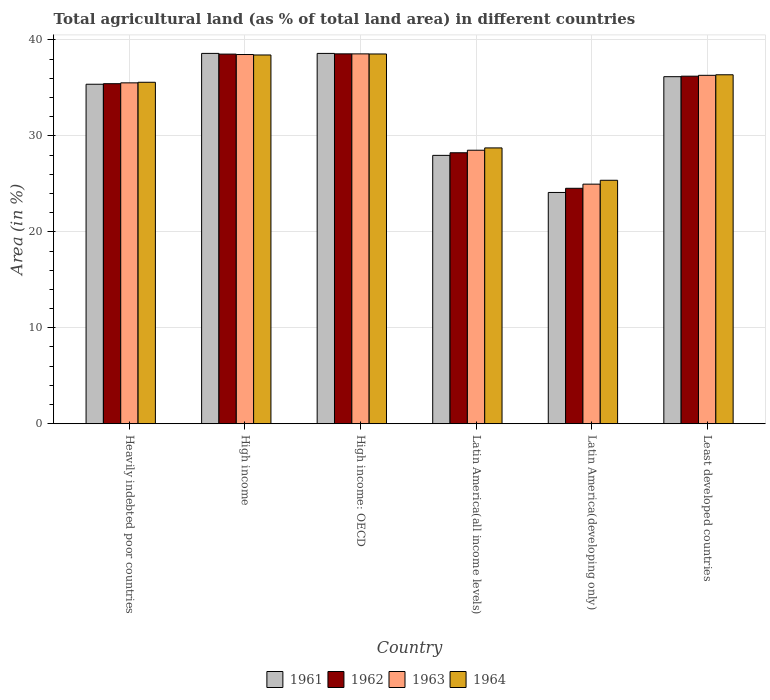How many groups of bars are there?
Your response must be concise. 6. Are the number of bars on each tick of the X-axis equal?
Make the answer very short. Yes. How many bars are there on the 4th tick from the right?
Ensure brevity in your answer.  4. What is the label of the 4th group of bars from the left?
Make the answer very short. Latin America(all income levels). What is the percentage of agricultural land in 1963 in Heavily indebted poor countries?
Make the answer very short. 35.52. Across all countries, what is the maximum percentage of agricultural land in 1964?
Make the answer very short. 38.53. Across all countries, what is the minimum percentage of agricultural land in 1961?
Offer a very short reply. 24.1. In which country was the percentage of agricultural land in 1964 maximum?
Give a very brief answer. High income: OECD. In which country was the percentage of agricultural land in 1962 minimum?
Offer a very short reply. Latin America(developing only). What is the total percentage of agricultural land in 1961 in the graph?
Keep it short and to the point. 200.81. What is the difference between the percentage of agricultural land in 1961 in Latin America(developing only) and that in Least developed countries?
Provide a short and direct response. -12.07. What is the difference between the percentage of agricultural land in 1964 in Latin America(all income levels) and the percentage of agricultural land in 1962 in High income: OECD?
Offer a very short reply. -9.8. What is the average percentage of agricultural land in 1962 per country?
Your response must be concise. 33.58. What is the difference between the percentage of agricultural land of/in 1964 and percentage of agricultural land of/in 1962 in High income?
Ensure brevity in your answer.  -0.09. What is the ratio of the percentage of agricultural land in 1961 in Heavily indebted poor countries to that in High income?
Provide a short and direct response. 0.92. What is the difference between the highest and the second highest percentage of agricultural land in 1962?
Provide a short and direct response. 2.3. What is the difference between the highest and the lowest percentage of agricultural land in 1962?
Keep it short and to the point. 14.01. Is the sum of the percentage of agricultural land in 1964 in Heavily indebted poor countries and Latin America(all income levels) greater than the maximum percentage of agricultural land in 1961 across all countries?
Provide a short and direct response. Yes. Is it the case that in every country, the sum of the percentage of agricultural land in 1963 and percentage of agricultural land in 1961 is greater than the sum of percentage of agricultural land in 1962 and percentage of agricultural land in 1964?
Give a very brief answer. No. What does the 1st bar from the right in Heavily indebted poor countries represents?
Offer a very short reply. 1964. How many bars are there?
Provide a short and direct response. 24. Are all the bars in the graph horizontal?
Give a very brief answer. No. How many countries are there in the graph?
Your answer should be compact. 6. What is the difference between two consecutive major ticks on the Y-axis?
Give a very brief answer. 10. Where does the legend appear in the graph?
Provide a succinct answer. Bottom center. How many legend labels are there?
Offer a terse response. 4. What is the title of the graph?
Offer a terse response. Total agricultural land (as % of total land area) in different countries. Does "1986" appear as one of the legend labels in the graph?
Make the answer very short. No. What is the label or title of the X-axis?
Ensure brevity in your answer.  Country. What is the label or title of the Y-axis?
Provide a short and direct response. Area (in %). What is the Area (in %) of 1961 in Heavily indebted poor countries?
Make the answer very short. 35.38. What is the Area (in %) in 1962 in Heavily indebted poor countries?
Make the answer very short. 35.44. What is the Area (in %) of 1963 in Heavily indebted poor countries?
Give a very brief answer. 35.52. What is the Area (in %) of 1964 in Heavily indebted poor countries?
Your response must be concise. 35.59. What is the Area (in %) of 1961 in High income?
Your response must be concise. 38.59. What is the Area (in %) of 1962 in High income?
Your answer should be compact. 38.52. What is the Area (in %) in 1963 in High income?
Give a very brief answer. 38.48. What is the Area (in %) of 1964 in High income?
Your answer should be very brief. 38.43. What is the Area (in %) of 1961 in High income: OECD?
Provide a succinct answer. 38.59. What is the Area (in %) in 1962 in High income: OECD?
Keep it short and to the point. 38.55. What is the Area (in %) of 1963 in High income: OECD?
Offer a terse response. 38.54. What is the Area (in %) in 1964 in High income: OECD?
Your answer should be very brief. 38.53. What is the Area (in %) of 1961 in Latin America(all income levels)?
Provide a short and direct response. 27.97. What is the Area (in %) of 1962 in Latin America(all income levels)?
Keep it short and to the point. 28.24. What is the Area (in %) in 1963 in Latin America(all income levels)?
Offer a terse response. 28.5. What is the Area (in %) in 1964 in Latin America(all income levels)?
Provide a short and direct response. 28.74. What is the Area (in %) of 1961 in Latin America(developing only)?
Offer a very short reply. 24.1. What is the Area (in %) of 1962 in Latin America(developing only)?
Your response must be concise. 24.54. What is the Area (in %) in 1963 in Latin America(developing only)?
Your answer should be very brief. 24.97. What is the Area (in %) of 1964 in Latin America(developing only)?
Keep it short and to the point. 25.37. What is the Area (in %) in 1961 in Least developed countries?
Your answer should be very brief. 36.17. What is the Area (in %) of 1962 in Least developed countries?
Offer a terse response. 36.22. What is the Area (in %) of 1963 in Least developed countries?
Provide a succinct answer. 36.31. What is the Area (in %) in 1964 in Least developed countries?
Your answer should be very brief. 36.37. Across all countries, what is the maximum Area (in %) of 1961?
Your answer should be compact. 38.59. Across all countries, what is the maximum Area (in %) in 1962?
Provide a succinct answer. 38.55. Across all countries, what is the maximum Area (in %) in 1963?
Your answer should be compact. 38.54. Across all countries, what is the maximum Area (in %) in 1964?
Ensure brevity in your answer.  38.53. Across all countries, what is the minimum Area (in %) of 1961?
Provide a succinct answer. 24.1. Across all countries, what is the minimum Area (in %) of 1962?
Ensure brevity in your answer.  24.54. Across all countries, what is the minimum Area (in %) of 1963?
Give a very brief answer. 24.97. Across all countries, what is the minimum Area (in %) in 1964?
Make the answer very short. 25.37. What is the total Area (in %) of 1961 in the graph?
Give a very brief answer. 200.81. What is the total Area (in %) in 1962 in the graph?
Your answer should be very brief. 201.5. What is the total Area (in %) in 1963 in the graph?
Keep it short and to the point. 202.33. What is the total Area (in %) of 1964 in the graph?
Provide a succinct answer. 203.03. What is the difference between the Area (in %) of 1961 in Heavily indebted poor countries and that in High income?
Make the answer very short. -3.21. What is the difference between the Area (in %) in 1962 in Heavily indebted poor countries and that in High income?
Ensure brevity in your answer.  -3.08. What is the difference between the Area (in %) of 1963 in Heavily indebted poor countries and that in High income?
Your answer should be very brief. -2.95. What is the difference between the Area (in %) of 1964 in Heavily indebted poor countries and that in High income?
Your answer should be compact. -2.84. What is the difference between the Area (in %) in 1961 in Heavily indebted poor countries and that in High income: OECD?
Make the answer very short. -3.21. What is the difference between the Area (in %) in 1962 in Heavily indebted poor countries and that in High income: OECD?
Offer a terse response. -3.11. What is the difference between the Area (in %) of 1963 in Heavily indebted poor countries and that in High income: OECD?
Keep it short and to the point. -3.02. What is the difference between the Area (in %) of 1964 in Heavily indebted poor countries and that in High income: OECD?
Your response must be concise. -2.95. What is the difference between the Area (in %) of 1961 in Heavily indebted poor countries and that in Latin America(all income levels)?
Make the answer very short. 7.41. What is the difference between the Area (in %) of 1962 in Heavily indebted poor countries and that in Latin America(all income levels)?
Provide a succinct answer. 7.2. What is the difference between the Area (in %) of 1963 in Heavily indebted poor countries and that in Latin America(all income levels)?
Offer a terse response. 7.02. What is the difference between the Area (in %) of 1964 in Heavily indebted poor countries and that in Latin America(all income levels)?
Ensure brevity in your answer.  6.84. What is the difference between the Area (in %) in 1961 in Heavily indebted poor countries and that in Latin America(developing only)?
Ensure brevity in your answer.  11.28. What is the difference between the Area (in %) of 1962 in Heavily indebted poor countries and that in Latin America(developing only)?
Your answer should be very brief. 10.9. What is the difference between the Area (in %) of 1963 in Heavily indebted poor countries and that in Latin America(developing only)?
Offer a very short reply. 10.56. What is the difference between the Area (in %) of 1964 in Heavily indebted poor countries and that in Latin America(developing only)?
Your answer should be compact. 10.21. What is the difference between the Area (in %) of 1961 in Heavily indebted poor countries and that in Least developed countries?
Make the answer very short. -0.79. What is the difference between the Area (in %) in 1962 in Heavily indebted poor countries and that in Least developed countries?
Your response must be concise. -0.78. What is the difference between the Area (in %) of 1963 in Heavily indebted poor countries and that in Least developed countries?
Offer a very short reply. -0.79. What is the difference between the Area (in %) in 1964 in Heavily indebted poor countries and that in Least developed countries?
Keep it short and to the point. -0.78. What is the difference between the Area (in %) of 1961 in High income and that in High income: OECD?
Provide a short and direct response. 0. What is the difference between the Area (in %) in 1962 in High income and that in High income: OECD?
Your answer should be compact. -0.03. What is the difference between the Area (in %) of 1963 in High income and that in High income: OECD?
Give a very brief answer. -0.07. What is the difference between the Area (in %) of 1964 in High income and that in High income: OECD?
Provide a short and direct response. -0.11. What is the difference between the Area (in %) in 1961 in High income and that in Latin America(all income levels)?
Offer a very short reply. 10.63. What is the difference between the Area (in %) in 1962 in High income and that in Latin America(all income levels)?
Provide a succinct answer. 10.28. What is the difference between the Area (in %) of 1963 in High income and that in Latin America(all income levels)?
Your answer should be very brief. 9.97. What is the difference between the Area (in %) in 1964 in High income and that in Latin America(all income levels)?
Provide a succinct answer. 9.68. What is the difference between the Area (in %) of 1961 in High income and that in Latin America(developing only)?
Make the answer very short. 14.49. What is the difference between the Area (in %) in 1962 in High income and that in Latin America(developing only)?
Make the answer very short. 13.98. What is the difference between the Area (in %) of 1963 in High income and that in Latin America(developing only)?
Provide a succinct answer. 13.51. What is the difference between the Area (in %) in 1964 in High income and that in Latin America(developing only)?
Offer a terse response. 13.06. What is the difference between the Area (in %) of 1961 in High income and that in Least developed countries?
Your response must be concise. 2.43. What is the difference between the Area (in %) in 1962 in High income and that in Least developed countries?
Make the answer very short. 2.3. What is the difference between the Area (in %) in 1963 in High income and that in Least developed countries?
Offer a terse response. 2.17. What is the difference between the Area (in %) of 1964 in High income and that in Least developed countries?
Your answer should be compact. 2.06. What is the difference between the Area (in %) of 1961 in High income: OECD and that in Latin America(all income levels)?
Give a very brief answer. 10.62. What is the difference between the Area (in %) in 1962 in High income: OECD and that in Latin America(all income levels)?
Provide a succinct answer. 10.31. What is the difference between the Area (in %) in 1963 in High income: OECD and that in Latin America(all income levels)?
Your response must be concise. 10.04. What is the difference between the Area (in %) in 1964 in High income: OECD and that in Latin America(all income levels)?
Give a very brief answer. 9.79. What is the difference between the Area (in %) of 1961 in High income: OECD and that in Latin America(developing only)?
Offer a terse response. 14.49. What is the difference between the Area (in %) in 1962 in High income: OECD and that in Latin America(developing only)?
Offer a very short reply. 14.01. What is the difference between the Area (in %) of 1963 in High income: OECD and that in Latin America(developing only)?
Offer a very short reply. 13.58. What is the difference between the Area (in %) of 1964 in High income: OECD and that in Latin America(developing only)?
Ensure brevity in your answer.  13.16. What is the difference between the Area (in %) in 1961 in High income: OECD and that in Least developed countries?
Provide a succinct answer. 2.42. What is the difference between the Area (in %) of 1962 in High income: OECD and that in Least developed countries?
Provide a succinct answer. 2.33. What is the difference between the Area (in %) of 1963 in High income: OECD and that in Least developed countries?
Ensure brevity in your answer.  2.23. What is the difference between the Area (in %) of 1964 in High income: OECD and that in Least developed countries?
Your response must be concise. 2.17. What is the difference between the Area (in %) of 1961 in Latin America(all income levels) and that in Latin America(developing only)?
Your response must be concise. 3.87. What is the difference between the Area (in %) in 1962 in Latin America(all income levels) and that in Latin America(developing only)?
Give a very brief answer. 3.7. What is the difference between the Area (in %) in 1963 in Latin America(all income levels) and that in Latin America(developing only)?
Provide a succinct answer. 3.53. What is the difference between the Area (in %) in 1964 in Latin America(all income levels) and that in Latin America(developing only)?
Offer a terse response. 3.37. What is the difference between the Area (in %) of 1961 in Latin America(all income levels) and that in Least developed countries?
Give a very brief answer. -8.2. What is the difference between the Area (in %) in 1962 in Latin America(all income levels) and that in Least developed countries?
Offer a terse response. -7.98. What is the difference between the Area (in %) in 1963 in Latin America(all income levels) and that in Least developed countries?
Offer a very short reply. -7.81. What is the difference between the Area (in %) in 1964 in Latin America(all income levels) and that in Least developed countries?
Your answer should be compact. -7.62. What is the difference between the Area (in %) in 1961 in Latin America(developing only) and that in Least developed countries?
Your answer should be compact. -12.07. What is the difference between the Area (in %) of 1962 in Latin America(developing only) and that in Least developed countries?
Offer a very short reply. -11.68. What is the difference between the Area (in %) of 1963 in Latin America(developing only) and that in Least developed countries?
Your response must be concise. -11.34. What is the difference between the Area (in %) in 1964 in Latin America(developing only) and that in Least developed countries?
Give a very brief answer. -10.99. What is the difference between the Area (in %) of 1961 in Heavily indebted poor countries and the Area (in %) of 1962 in High income?
Ensure brevity in your answer.  -3.14. What is the difference between the Area (in %) in 1961 in Heavily indebted poor countries and the Area (in %) in 1963 in High income?
Your answer should be compact. -3.1. What is the difference between the Area (in %) in 1961 in Heavily indebted poor countries and the Area (in %) in 1964 in High income?
Make the answer very short. -3.05. What is the difference between the Area (in %) in 1962 in Heavily indebted poor countries and the Area (in %) in 1963 in High income?
Offer a terse response. -3.04. What is the difference between the Area (in %) in 1962 in Heavily indebted poor countries and the Area (in %) in 1964 in High income?
Your answer should be compact. -2.99. What is the difference between the Area (in %) of 1963 in Heavily indebted poor countries and the Area (in %) of 1964 in High income?
Your answer should be compact. -2.9. What is the difference between the Area (in %) in 1961 in Heavily indebted poor countries and the Area (in %) in 1962 in High income: OECD?
Provide a succinct answer. -3.17. What is the difference between the Area (in %) of 1961 in Heavily indebted poor countries and the Area (in %) of 1963 in High income: OECD?
Give a very brief answer. -3.16. What is the difference between the Area (in %) in 1961 in Heavily indebted poor countries and the Area (in %) in 1964 in High income: OECD?
Make the answer very short. -3.15. What is the difference between the Area (in %) of 1962 in Heavily indebted poor countries and the Area (in %) of 1963 in High income: OECD?
Ensure brevity in your answer.  -3.11. What is the difference between the Area (in %) in 1962 in Heavily indebted poor countries and the Area (in %) in 1964 in High income: OECD?
Offer a terse response. -3.1. What is the difference between the Area (in %) in 1963 in Heavily indebted poor countries and the Area (in %) in 1964 in High income: OECD?
Your answer should be very brief. -3.01. What is the difference between the Area (in %) in 1961 in Heavily indebted poor countries and the Area (in %) in 1962 in Latin America(all income levels)?
Provide a short and direct response. 7.14. What is the difference between the Area (in %) of 1961 in Heavily indebted poor countries and the Area (in %) of 1963 in Latin America(all income levels)?
Provide a short and direct response. 6.88. What is the difference between the Area (in %) of 1961 in Heavily indebted poor countries and the Area (in %) of 1964 in Latin America(all income levels)?
Make the answer very short. 6.64. What is the difference between the Area (in %) of 1962 in Heavily indebted poor countries and the Area (in %) of 1963 in Latin America(all income levels)?
Make the answer very short. 6.93. What is the difference between the Area (in %) in 1962 in Heavily indebted poor countries and the Area (in %) in 1964 in Latin America(all income levels)?
Your answer should be compact. 6.69. What is the difference between the Area (in %) of 1963 in Heavily indebted poor countries and the Area (in %) of 1964 in Latin America(all income levels)?
Give a very brief answer. 6.78. What is the difference between the Area (in %) in 1961 in Heavily indebted poor countries and the Area (in %) in 1962 in Latin America(developing only)?
Offer a very short reply. 10.84. What is the difference between the Area (in %) of 1961 in Heavily indebted poor countries and the Area (in %) of 1963 in Latin America(developing only)?
Offer a very short reply. 10.41. What is the difference between the Area (in %) in 1961 in Heavily indebted poor countries and the Area (in %) in 1964 in Latin America(developing only)?
Make the answer very short. 10.01. What is the difference between the Area (in %) in 1962 in Heavily indebted poor countries and the Area (in %) in 1963 in Latin America(developing only)?
Ensure brevity in your answer.  10.47. What is the difference between the Area (in %) of 1962 in Heavily indebted poor countries and the Area (in %) of 1964 in Latin America(developing only)?
Give a very brief answer. 10.07. What is the difference between the Area (in %) of 1963 in Heavily indebted poor countries and the Area (in %) of 1964 in Latin America(developing only)?
Make the answer very short. 10.15. What is the difference between the Area (in %) of 1961 in Heavily indebted poor countries and the Area (in %) of 1962 in Least developed countries?
Provide a short and direct response. -0.84. What is the difference between the Area (in %) in 1961 in Heavily indebted poor countries and the Area (in %) in 1963 in Least developed countries?
Your answer should be compact. -0.93. What is the difference between the Area (in %) of 1961 in Heavily indebted poor countries and the Area (in %) of 1964 in Least developed countries?
Give a very brief answer. -0.99. What is the difference between the Area (in %) in 1962 in Heavily indebted poor countries and the Area (in %) in 1963 in Least developed countries?
Your response must be concise. -0.87. What is the difference between the Area (in %) in 1962 in Heavily indebted poor countries and the Area (in %) in 1964 in Least developed countries?
Your answer should be very brief. -0.93. What is the difference between the Area (in %) in 1963 in Heavily indebted poor countries and the Area (in %) in 1964 in Least developed countries?
Keep it short and to the point. -0.84. What is the difference between the Area (in %) of 1961 in High income and the Area (in %) of 1962 in High income: OECD?
Give a very brief answer. 0.05. What is the difference between the Area (in %) of 1961 in High income and the Area (in %) of 1963 in High income: OECD?
Provide a short and direct response. 0.05. What is the difference between the Area (in %) in 1961 in High income and the Area (in %) in 1964 in High income: OECD?
Your response must be concise. 0.06. What is the difference between the Area (in %) in 1962 in High income and the Area (in %) in 1963 in High income: OECD?
Provide a succinct answer. -0.02. What is the difference between the Area (in %) of 1962 in High income and the Area (in %) of 1964 in High income: OECD?
Provide a short and direct response. -0.01. What is the difference between the Area (in %) in 1963 in High income and the Area (in %) in 1964 in High income: OECD?
Your response must be concise. -0.06. What is the difference between the Area (in %) in 1961 in High income and the Area (in %) in 1962 in Latin America(all income levels)?
Ensure brevity in your answer.  10.36. What is the difference between the Area (in %) of 1961 in High income and the Area (in %) of 1963 in Latin America(all income levels)?
Ensure brevity in your answer.  10.09. What is the difference between the Area (in %) in 1961 in High income and the Area (in %) in 1964 in Latin America(all income levels)?
Offer a terse response. 9.85. What is the difference between the Area (in %) in 1962 in High income and the Area (in %) in 1963 in Latin America(all income levels)?
Keep it short and to the point. 10.02. What is the difference between the Area (in %) in 1962 in High income and the Area (in %) in 1964 in Latin America(all income levels)?
Make the answer very short. 9.78. What is the difference between the Area (in %) of 1963 in High income and the Area (in %) of 1964 in Latin America(all income levels)?
Ensure brevity in your answer.  9.73. What is the difference between the Area (in %) of 1961 in High income and the Area (in %) of 1962 in Latin America(developing only)?
Ensure brevity in your answer.  14.06. What is the difference between the Area (in %) in 1961 in High income and the Area (in %) in 1963 in Latin America(developing only)?
Your answer should be compact. 13.63. What is the difference between the Area (in %) of 1961 in High income and the Area (in %) of 1964 in Latin America(developing only)?
Ensure brevity in your answer.  13.22. What is the difference between the Area (in %) of 1962 in High income and the Area (in %) of 1963 in Latin America(developing only)?
Your answer should be very brief. 13.55. What is the difference between the Area (in %) in 1962 in High income and the Area (in %) in 1964 in Latin America(developing only)?
Your response must be concise. 13.15. What is the difference between the Area (in %) in 1963 in High income and the Area (in %) in 1964 in Latin America(developing only)?
Your answer should be compact. 13.11. What is the difference between the Area (in %) in 1961 in High income and the Area (in %) in 1962 in Least developed countries?
Ensure brevity in your answer.  2.37. What is the difference between the Area (in %) in 1961 in High income and the Area (in %) in 1963 in Least developed countries?
Keep it short and to the point. 2.29. What is the difference between the Area (in %) in 1961 in High income and the Area (in %) in 1964 in Least developed countries?
Give a very brief answer. 2.23. What is the difference between the Area (in %) of 1962 in High income and the Area (in %) of 1963 in Least developed countries?
Offer a very short reply. 2.21. What is the difference between the Area (in %) in 1962 in High income and the Area (in %) in 1964 in Least developed countries?
Your response must be concise. 2.15. What is the difference between the Area (in %) in 1963 in High income and the Area (in %) in 1964 in Least developed countries?
Offer a very short reply. 2.11. What is the difference between the Area (in %) of 1961 in High income: OECD and the Area (in %) of 1962 in Latin America(all income levels)?
Ensure brevity in your answer.  10.35. What is the difference between the Area (in %) of 1961 in High income: OECD and the Area (in %) of 1963 in Latin America(all income levels)?
Provide a succinct answer. 10.09. What is the difference between the Area (in %) in 1961 in High income: OECD and the Area (in %) in 1964 in Latin America(all income levels)?
Provide a short and direct response. 9.85. What is the difference between the Area (in %) in 1962 in High income: OECD and the Area (in %) in 1963 in Latin America(all income levels)?
Ensure brevity in your answer.  10.04. What is the difference between the Area (in %) of 1962 in High income: OECD and the Area (in %) of 1964 in Latin America(all income levels)?
Your answer should be very brief. 9.8. What is the difference between the Area (in %) of 1963 in High income: OECD and the Area (in %) of 1964 in Latin America(all income levels)?
Your answer should be compact. 9.8. What is the difference between the Area (in %) in 1961 in High income: OECD and the Area (in %) in 1962 in Latin America(developing only)?
Make the answer very short. 14.06. What is the difference between the Area (in %) in 1961 in High income: OECD and the Area (in %) in 1963 in Latin America(developing only)?
Provide a short and direct response. 13.62. What is the difference between the Area (in %) in 1961 in High income: OECD and the Area (in %) in 1964 in Latin America(developing only)?
Make the answer very short. 13.22. What is the difference between the Area (in %) in 1962 in High income: OECD and the Area (in %) in 1963 in Latin America(developing only)?
Provide a short and direct response. 13.58. What is the difference between the Area (in %) in 1962 in High income: OECD and the Area (in %) in 1964 in Latin America(developing only)?
Your response must be concise. 13.17. What is the difference between the Area (in %) of 1963 in High income: OECD and the Area (in %) of 1964 in Latin America(developing only)?
Offer a terse response. 13.17. What is the difference between the Area (in %) of 1961 in High income: OECD and the Area (in %) of 1962 in Least developed countries?
Keep it short and to the point. 2.37. What is the difference between the Area (in %) of 1961 in High income: OECD and the Area (in %) of 1963 in Least developed countries?
Provide a succinct answer. 2.28. What is the difference between the Area (in %) in 1961 in High income: OECD and the Area (in %) in 1964 in Least developed countries?
Provide a short and direct response. 2.23. What is the difference between the Area (in %) of 1962 in High income: OECD and the Area (in %) of 1963 in Least developed countries?
Your response must be concise. 2.24. What is the difference between the Area (in %) in 1962 in High income: OECD and the Area (in %) in 1964 in Least developed countries?
Give a very brief answer. 2.18. What is the difference between the Area (in %) in 1963 in High income: OECD and the Area (in %) in 1964 in Least developed countries?
Ensure brevity in your answer.  2.18. What is the difference between the Area (in %) in 1961 in Latin America(all income levels) and the Area (in %) in 1962 in Latin America(developing only)?
Keep it short and to the point. 3.43. What is the difference between the Area (in %) of 1961 in Latin America(all income levels) and the Area (in %) of 1963 in Latin America(developing only)?
Give a very brief answer. 3. What is the difference between the Area (in %) in 1961 in Latin America(all income levels) and the Area (in %) in 1964 in Latin America(developing only)?
Keep it short and to the point. 2.6. What is the difference between the Area (in %) of 1962 in Latin America(all income levels) and the Area (in %) of 1963 in Latin America(developing only)?
Ensure brevity in your answer.  3.27. What is the difference between the Area (in %) in 1962 in Latin America(all income levels) and the Area (in %) in 1964 in Latin America(developing only)?
Make the answer very short. 2.87. What is the difference between the Area (in %) of 1963 in Latin America(all income levels) and the Area (in %) of 1964 in Latin America(developing only)?
Provide a succinct answer. 3.13. What is the difference between the Area (in %) of 1961 in Latin America(all income levels) and the Area (in %) of 1962 in Least developed countries?
Provide a succinct answer. -8.25. What is the difference between the Area (in %) in 1961 in Latin America(all income levels) and the Area (in %) in 1963 in Least developed countries?
Your answer should be compact. -8.34. What is the difference between the Area (in %) in 1961 in Latin America(all income levels) and the Area (in %) in 1964 in Least developed countries?
Ensure brevity in your answer.  -8.4. What is the difference between the Area (in %) in 1962 in Latin America(all income levels) and the Area (in %) in 1963 in Least developed countries?
Give a very brief answer. -8.07. What is the difference between the Area (in %) of 1962 in Latin America(all income levels) and the Area (in %) of 1964 in Least developed countries?
Offer a very short reply. -8.13. What is the difference between the Area (in %) of 1963 in Latin America(all income levels) and the Area (in %) of 1964 in Least developed countries?
Your response must be concise. -7.86. What is the difference between the Area (in %) of 1961 in Latin America(developing only) and the Area (in %) of 1962 in Least developed countries?
Your response must be concise. -12.12. What is the difference between the Area (in %) of 1961 in Latin America(developing only) and the Area (in %) of 1963 in Least developed countries?
Offer a very short reply. -12.21. What is the difference between the Area (in %) in 1961 in Latin America(developing only) and the Area (in %) in 1964 in Least developed countries?
Your answer should be very brief. -12.26. What is the difference between the Area (in %) of 1962 in Latin America(developing only) and the Area (in %) of 1963 in Least developed countries?
Give a very brief answer. -11.77. What is the difference between the Area (in %) in 1962 in Latin America(developing only) and the Area (in %) in 1964 in Least developed countries?
Ensure brevity in your answer.  -11.83. What is the difference between the Area (in %) in 1963 in Latin America(developing only) and the Area (in %) in 1964 in Least developed countries?
Provide a short and direct response. -11.4. What is the average Area (in %) of 1961 per country?
Make the answer very short. 33.47. What is the average Area (in %) of 1962 per country?
Provide a succinct answer. 33.58. What is the average Area (in %) in 1963 per country?
Keep it short and to the point. 33.72. What is the average Area (in %) of 1964 per country?
Ensure brevity in your answer.  33.84. What is the difference between the Area (in %) in 1961 and Area (in %) in 1962 in Heavily indebted poor countries?
Give a very brief answer. -0.06. What is the difference between the Area (in %) in 1961 and Area (in %) in 1963 in Heavily indebted poor countries?
Your answer should be very brief. -0.14. What is the difference between the Area (in %) in 1961 and Area (in %) in 1964 in Heavily indebted poor countries?
Offer a terse response. -0.2. What is the difference between the Area (in %) of 1962 and Area (in %) of 1963 in Heavily indebted poor countries?
Your response must be concise. -0.09. What is the difference between the Area (in %) in 1962 and Area (in %) in 1964 in Heavily indebted poor countries?
Offer a very short reply. -0.15. What is the difference between the Area (in %) in 1963 and Area (in %) in 1964 in Heavily indebted poor countries?
Provide a succinct answer. -0.06. What is the difference between the Area (in %) of 1961 and Area (in %) of 1962 in High income?
Provide a short and direct response. 0.07. What is the difference between the Area (in %) of 1961 and Area (in %) of 1963 in High income?
Offer a very short reply. 0.12. What is the difference between the Area (in %) of 1961 and Area (in %) of 1964 in High income?
Your response must be concise. 0.17. What is the difference between the Area (in %) of 1962 and Area (in %) of 1963 in High income?
Provide a succinct answer. 0.04. What is the difference between the Area (in %) of 1962 and Area (in %) of 1964 in High income?
Your response must be concise. 0.09. What is the difference between the Area (in %) in 1963 and Area (in %) in 1964 in High income?
Keep it short and to the point. 0.05. What is the difference between the Area (in %) of 1961 and Area (in %) of 1962 in High income: OECD?
Offer a very short reply. 0.04. What is the difference between the Area (in %) in 1961 and Area (in %) in 1963 in High income: OECD?
Provide a short and direct response. 0.05. What is the difference between the Area (in %) of 1961 and Area (in %) of 1964 in High income: OECD?
Provide a succinct answer. 0.06. What is the difference between the Area (in %) in 1962 and Area (in %) in 1963 in High income: OECD?
Your answer should be very brief. 0. What is the difference between the Area (in %) of 1962 and Area (in %) of 1964 in High income: OECD?
Keep it short and to the point. 0.01. What is the difference between the Area (in %) of 1963 and Area (in %) of 1964 in High income: OECD?
Offer a terse response. 0.01. What is the difference between the Area (in %) of 1961 and Area (in %) of 1962 in Latin America(all income levels)?
Ensure brevity in your answer.  -0.27. What is the difference between the Area (in %) of 1961 and Area (in %) of 1963 in Latin America(all income levels)?
Offer a very short reply. -0.54. What is the difference between the Area (in %) in 1961 and Area (in %) in 1964 in Latin America(all income levels)?
Ensure brevity in your answer.  -0.78. What is the difference between the Area (in %) in 1962 and Area (in %) in 1963 in Latin America(all income levels)?
Provide a succinct answer. -0.26. What is the difference between the Area (in %) of 1962 and Area (in %) of 1964 in Latin America(all income levels)?
Your answer should be very brief. -0.51. What is the difference between the Area (in %) of 1963 and Area (in %) of 1964 in Latin America(all income levels)?
Your response must be concise. -0.24. What is the difference between the Area (in %) in 1961 and Area (in %) in 1962 in Latin America(developing only)?
Ensure brevity in your answer.  -0.43. What is the difference between the Area (in %) of 1961 and Area (in %) of 1963 in Latin America(developing only)?
Make the answer very short. -0.87. What is the difference between the Area (in %) in 1961 and Area (in %) in 1964 in Latin America(developing only)?
Ensure brevity in your answer.  -1.27. What is the difference between the Area (in %) in 1962 and Area (in %) in 1963 in Latin America(developing only)?
Provide a succinct answer. -0.43. What is the difference between the Area (in %) of 1962 and Area (in %) of 1964 in Latin America(developing only)?
Provide a succinct answer. -0.84. What is the difference between the Area (in %) of 1963 and Area (in %) of 1964 in Latin America(developing only)?
Your answer should be very brief. -0.4. What is the difference between the Area (in %) in 1961 and Area (in %) in 1962 in Least developed countries?
Your answer should be very brief. -0.05. What is the difference between the Area (in %) in 1961 and Area (in %) in 1963 in Least developed countries?
Offer a very short reply. -0.14. What is the difference between the Area (in %) of 1961 and Area (in %) of 1964 in Least developed countries?
Offer a terse response. -0.2. What is the difference between the Area (in %) of 1962 and Area (in %) of 1963 in Least developed countries?
Your answer should be compact. -0.09. What is the difference between the Area (in %) of 1962 and Area (in %) of 1964 in Least developed countries?
Offer a terse response. -0.15. What is the difference between the Area (in %) in 1963 and Area (in %) in 1964 in Least developed countries?
Provide a succinct answer. -0.06. What is the ratio of the Area (in %) in 1962 in Heavily indebted poor countries to that in High income?
Provide a succinct answer. 0.92. What is the ratio of the Area (in %) in 1963 in Heavily indebted poor countries to that in High income?
Keep it short and to the point. 0.92. What is the ratio of the Area (in %) in 1964 in Heavily indebted poor countries to that in High income?
Your answer should be very brief. 0.93. What is the ratio of the Area (in %) in 1961 in Heavily indebted poor countries to that in High income: OECD?
Ensure brevity in your answer.  0.92. What is the ratio of the Area (in %) in 1962 in Heavily indebted poor countries to that in High income: OECD?
Your answer should be compact. 0.92. What is the ratio of the Area (in %) in 1963 in Heavily indebted poor countries to that in High income: OECD?
Keep it short and to the point. 0.92. What is the ratio of the Area (in %) of 1964 in Heavily indebted poor countries to that in High income: OECD?
Offer a terse response. 0.92. What is the ratio of the Area (in %) in 1961 in Heavily indebted poor countries to that in Latin America(all income levels)?
Provide a succinct answer. 1.26. What is the ratio of the Area (in %) in 1962 in Heavily indebted poor countries to that in Latin America(all income levels)?
Your response must be concise. 1.25. What is the ratio of the Area (in %) in 1963 in Heavily indebted poor countries to that in Latin America(all income levels)?
Provide a short and direct response. 1.25. What is the ratio of the Area (in %) in 1964 in Heavily indebted poor countries to that in Latin America(all income levels)?
Your response must be concise. 1.24. What is the ratio of the Area (in %) of 1961 in Heavily indebted poor countries to that in Latin America(developing only)?
Make the answer very short. 1.47. What is the ratio of the Area (in %) of 1962 in Heavily indebted poor countries to that in Latin America(developing only)?
Your response must be concise. 1.44. What is the ratio of the Area (in %) of 1963 in Heavily indebted poor countries to that in Latin America(developing only)?
Provide a short and direct response. 1.42. What is the ratio of the Area (in %) in 1964 in Heavily indebted poor countries to that in Latin America(developing only)?
Ensure brevity in your answer.  1.4. What is the ratio of the Area (in %) of 1961 in Heavily indebted poor countries to that in Least developed countries?
Give a very brief answer. 0.98. What is the ratio of the Area (in %) in 1962 in Heavily indebted poor countries to that in Least developed countries?
Keep it short and to the point. 0.98. What is the ratio of the Area (in %) of 1963 in Heavily indebted poor countries to that in Least developed countries?
Give a very brief answer. 0.98. What is the ratio of the Area (in %) in 1964 in Heavily indebted poor countries to that in Least developed countries?
Offer a terse response. 0.98. What is the ratio of the Area (in %) of 1961 in High income to that in High income: OECD?
Keep it short and to the point. 1. What is the ratio of the Area (in %) in 1962 in High income to that in High income: OECD?
Make the answer very short. 1. What is the ratio of the Area (in %) of 1963 in High income to that in High income: OECD?
Provide a short and direct response. 1. What is the ratio of the Area (in %) in 1961 in High income to that in Latin America(all income levels)?
Provide a succinct answer. 1.38. What is the ratio of the Area (in %) of 1962 in High income to that in Latin America(all income levels)?
Your response must be concise. 1.36. What is the ratio of the Area (in %) in 1963 in High income to that in Latin America(all income levels)?
Offer a very short reply. 1.35. What is the ratio of the Area (in %) of 1964 in High income to that in Latin America(all income levels)?
Your answer should be compact. 1.34. What is the ratio of the Area (in %) of 1961 in High income to that in Latin America(developing only)?
Make the answer very short. 1.6. What is the ratio of the Area (in %) of 1962 in High income to that in Latin America(developing only)?
Offer a terse response. 1.57. What is the ratio of the Area (in %) in 1963 in High income to that in Latin America(developing only)?
Your response must be concise. 1.54. What is the ratio of the Area (in %) in 1964 in High income to that in Latin America(developing only)?
Make the answer very short. 1.51. What is the ratio of the Area (in %) of 1961 in High income to that in Least developed countries?
Offer a very short reply. 1.07. What is the ratio of the Area (in %) of 1962 in High income to that in Least developed countries?
Ensure brevity in your answer.  1.06. What is the ratio of the Area (in %) in 1963 in High income to that in Least developed countries?
Your answer should be compact. 1.06. What is the ratio of the Area (in %) in 1964 in High income to that in Least developed countries?
Ensure brevity in your answer.  1.06. What is the ratio of the Area (in %) in 1961 in High income: OECD to that in Latin America(all income levels)?
Keep it short and to the point. 1.38. What is the ratio of the Area (in %) in 1962 in High income: OECD to that in Latin America(all income levels)?
Offer a terse response. 1.36. What is the ratio of the Area (in %) in 1963 in High income: OECD to that in Latin America(all income levels)?
Make the answer very short. 1.35. What is the ratio of the Area (in %) of 1964 in High income: OECD to that in Latin America(all income levels)?
Your answer should be compact. 1.34. What is the ratio of the Area (in %) in 1961 in High income: OECD to that in Latin America(developing only)?
Your answer should be very brief. 1.6. What is the ratio of the Area (in %) in 1962 in High income: OECD to that in Latin America(developing only)?
Your response must be concise. 1.57. What is the ratio of the Area (in %) in 1963 in High income: OECD to that in Latin America(developing only)?
Provide a succinct answer. 1.54. What is the ratio of the Area (in %) in 1964 in High income: OECD to that in Latin America(developing only)?
Your answer should be very brief. 1.52. What is the ratio of the Area (in %) in 1961 in High income: OECD to that in Least developed countries?
Make the answer very short. 1.07. What is the ratio of the Area (in %) of 1962 in High income: OECD to that in Least developed countries?
Your answer should be compact. 1.06. What is the ratio of the Area (in %) in 1963 in High income: OECD to that in Least developed countries?
Make the answer very short. 1.06. What is the ratio of the Area (in %) of 1964 in High income: OECD to that in Least developed countries?
Make the answer very short. 1.06. What is the ratio of the Area (in %) of 1961 in Latin America(all income levels) to that in Latin America(developing only)?
Your answer should be very brief. 1.16. What is the ratio of the Area (in %) of 1962 in Latin America(all income levels) to that in Latin America(developing only)?
Make the answer very short. 1.15. What is the ratio of the Area (in %) of 1963 in Latin America(all income levels) to that in Latin America(developing only)?
Offer a terse response. 1.14. What is the ratio of the Area (in %) of 1964 in Latin America(all income levels) to that in Latin America(developing only)?
Offer a terse response. 1.13. What is the ratio of the Area (in %) in 1961 in Latin America(all income levels) to that in Least developed countries?
Ensure brevity in your answer.  0.77. What is the ratio of the Area (in %) of 1962 in Latin America(all income levels) to that in Least developed countries?
Make the answer very short. 0.78. What is the ratio of the Area (in %) of 1963 in Latin America(all income levels) to that in Least developed countries?
Offer a very short reply. 0.79. What is the ratio of the Area (in %) in 1964 in Latin America(all income levels) to that in Least developed countries?
Keep it short and to the point. 0.79. What is the ratio of the Area (in %) in 1961 in Latin America(developing only) to that in Least developed countries?
Give a very brief answer. 0.67. What is the ratio of the Area (in %) in 1962 in Latin America(developing only) to that in Least developed countries?
Your answer should be very brief. 0.68. What is the ratio of the Area (in %) in 1963 in Latin America(developing only) to that in Least developed countries?
Offer a terse response. 0.69. What is the ratio of the Area (in %) in 1964 in Latin America(developing only) to that in Least developed countries?
Your answer should be compact. 0.7. What is the difference between the highest and the second highest Area (in %) in 1961?
Keep it short and to the point. 0. What is the difference between the highest and the second highest Area (in %) in 1962?
Make the answer very short. 0.03. What is the difference between the highest and the second highest Area (in %) in 1963?
Offer a terse response. 0.07. What is the difference between the highest and the second highest Area (in %) in 1964?
Make the answer very short. 0.11. What is the difference between the highest and the lowest Area (in %) in 1961?
Offer a terse response. 14.49. What is the difference between the highest and the lowest Area (in %) of 1962?
Make the answer very short. 14.01. What is the difference between the highest and the lowest Area (in %) of 1963?
Your answer should be compact. 13.58. What is the difference between the highest and the lowest Area (in %) in 1964?
Ensure brevity in your answer.  13.16. 